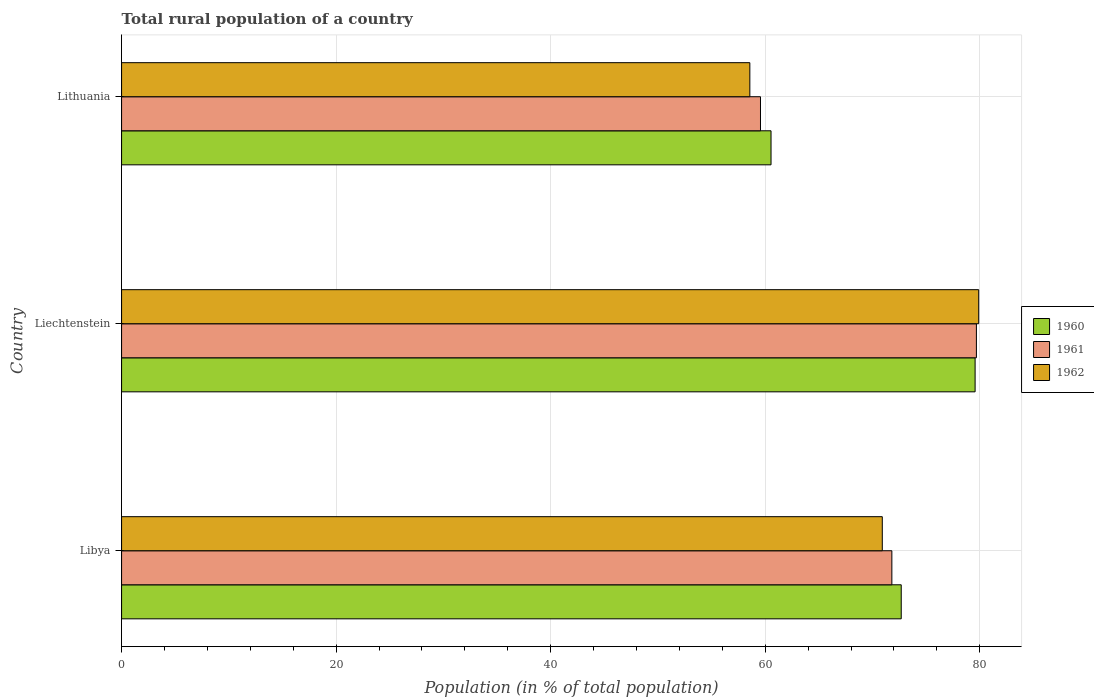How many different coloured bars are there?
Give a very brief answer. 3. Are the number of bars on each tick of the Y-axis equal?
Keep it short and to the point. Yes. How many bars are there on the 2nd tick from the top?
Ensure brevity in your answer.  3. How many bars are there on the 1st tick from the bottom?
Your response must be concise. 3. What is the label of the 1st group of bars from the top?
Provide a short and direct response. Lithuania. What is the rural population in 1962 in Lithuania?
Provide a succinct answer. 58.56. Across all countries, what is the maximum rural population in 1960?
Offer a terse response. 79.56. Across all countries, what is the minimum rural population in 1962?
Your response must be concise. 58.56. In which country was the rural population in 1962 maximum?
Give a very brief answer. Liechtenstein. In which country was the rural population in 1962 minimum?
Keep it short and to the point. Lithuania. What is the total rural population in 1961 in the graph?
Your response must be concise. 211.05. What is the difference between the rural population in 1962 in Libya and that in Liechtenstein?
Offer a terse response. -8.99. What is the difference between the rural population in 1962 in Lithuania and the rural population in 1960 in Libya?
Give a very brief answer. -14.11. What is the average rural population in 1962 per country?
Make the answer very short. 69.79. What is the difference between the rural population in 1961 and rural population in 1960 in Liechtenstein?
Offer a very short reply. 0.12. What is the ratio of the rural population in 1962 in Libya to that in Lithuania?
Provide a succinct answer. 1.21. What is the difference between the highest and the second highest rural population in 1962?
Provide a succinct answer. 8.99. What is the difference between the highest and the lowest rural population in 1961?
Offer a terse response. 20.13. What does the 1st bar from the top in Libya represents?
Provide a short and direct response. 1962. Is it the case that in every country, the sum of the rural population in 1962 and rural population in 1960 is greater than the rural population in 1961?
Offer a very short reply. Yes. How many bars are there?
Offer a very short reply. 9. Are all the bars in the graph horizontal?
Ensure brevity in your answer.  Yes. How many countries are there in the graph?
Offer a very short reply. 3. What is the difference between two consecutive major ticks on the X-axis?
Provide a short and direct response. 20. Does the graph contain any zero values?
Ensure brevity in your answer.  No. Where does the legend appear in the graph?
Offer a very short reply. Center right. How many legend labels are there?
Offer a terse response. 3. What is the title of the graph?
Provide a short and direct response. Total rural population of a country. What is the label or title of the X-axis?
Make the answer very short. Population (in % of total population). What is the label or title of the Y-axis?
Make the answer very short. Country. What is the Population (in % of total population) in 1960 in Libya?
Your answer should be compact. 72.68. What is the Population (in % of total population) of 1961 in Libya?
Keep it short and to the point. 71.8. What is the Population (in % of total population) in 1962 in Libya?
Offer a terse response. 70.91. What is the Population (in % of total population) in 1960 in Liechtenstein?
Offer a very short reply. 79.56. What is the Population (in % of total population) in 1961 in Liechtenstein?
Your answer should be very brief. 79.69. What is the Population (in % of total population) in 1962 in Liechtenstein?
Offer a terse response. 79.9. What is the Population (in % of total population) in 1960 in Lithuania?
Your answer should be very brief. 60.54. What is the Population (in % of total population) of 1961 in Lithuania?
Your answer should be compact. 59.56. What is the Population (in % of total population) in 1962 in Lithuania?
Your response must be concise. 58.56. Across all countries, what is the maximum Population (in % of total population) in 1960?
Your answer should be compact. 79.56. Across all countries, what is the maximum Population (in % of total population) of 1961?
Your response must be concise. 79.69. Across all countries, what is the maximum Population (in % of total population) in 1962?
Provide a short and direct response. 79.9. Across all countries, what is the minimum Population (in % of total population) of 1960?
Make the answer very short. 60.54. Across all countries, what is the minimum Population (in % of total population) in 1961?
Provide a succinct answer. 59.56. Across all countries, what is the minimum Population (in % of total population) in 1962?
Provide a succinct answer. 58.56. What is the total Population (in % of total population) of 1960 in the graph?
Offer a very short reply. 212.78. What is the total Population (in % of total population) of 1961 in the graph?
Your answer should be compact. 211.04. What is the total Population (in % of total population) of 1962 in the graph?
Offer a very short reply. 209.37. What is the difference between the Population (in % of total population) of 1960 in Libya and that in Liechtenstein?
Provide a succinct answer. -6.89. What is the difference between the Population (in % of total population) in 1961 in Libya and that in Liechtenstein?
Provide a short and direct response. -7.88. What is the difference between the Population (in % of total population) of 1962 in Libya and that in Liechtenstein?
Keep it short and to the point. -8.99. What is the difference between the Population (in % of total population) of 1960 in Libya and that in Lithuania?
Your answer should be very brief. 12.14. What is the difference between the Population (in % of total population) of 1961 in Libya and that in Lithuania?
Provide a succinct answer. 12.25. What is the difference between the Population (in % of total population) in 1962 in Libya and that in Lithuania?
Keep it short and to the point. 12.35. What is the difference between the Population (in % of total population) in 1960 in Liechtenstein and that in Lithuania?
Ensure brevity in your answer.  19.02. What is the difference between the Population (in % of total population) of 1961 in Liechtenstein and that in Lithuania?
Keep it short and to the point. 20.13. What is the difference between the Population (in % of total population) in 1962 in Liechtenstein and that in Lithuania?
Make the answer very short. 21.33. What is the difference between the Population (in % of total population) of 1960 in Libya and the Population (in % of total population) of 1961 in Liechtenstein?
Provide a succinct answer. -7.01. What is the difference between the Population (in % of total population) of 1960 in Libya and the Population (in % of total population) of 1962 in Liechtenstein?
Give a very brief answer. -7.22. What is the difference between the Population (in % of total population) of 1961 in Libya and the Population (in % of total population) of 1962 in Liechtenstein?
Your answer should be very brief. -8.1. What is the difference between the Population (in % of total population) of 1960 in Libya and the Population (in % of total population) of 1961 in Lithuania?
Provide a short and direct response. 13.12. What is the difference between the Population (in % of total population) in 1960 in Libya and the Population (in % of total population) in 1962 in Lithuania?
Give a very brief answer. 14.11. What is the difference between the Population (in % of total population) of 1961 in Libya and the Population (in % of total population) of 1962 in Lithuania?
Give a very brief answer. 13.24. What is the difference between the Population (in % of total population) in 1960 in Liechtenstein and the Population (in % of total population) in 1961 in Lithuania?
Provide a succinct answer. 20.01. What is the difference between the Population (in % of total population) in 1960 in Liechtenstein and the Population (in % of total population) in 1962 in Lithuania?
Make the answer very short. 21. What is the difference between the Population (in % of total population) in 1961 in Liechtenstein and the Population (in % of total population) in 1962 in Lithuania?
Keep it short and to the point. 21.12. What is the average Population (in % of total population) in 1960 per country?
Offer a very short reply. 70.93. What is the average Population (in % of total population) of 1961 per country?
Your answer should be very brief. 70.35. What is the average Population (in % of total population) in 1962 per country?
Provide a short and direct response. 69.79. What is the difference between the Population (in % of total population) in 1960 and Population (in % of total population) in 1961 in Libya?
Make the answer very short. 0.87. What is the difference between the Population (in % of total population) of 1960 and Population (in % of total population) of 1962 in Libya?
Provide a succinct answer. 1.77. What is the difference between the Population (in % of total population) in 1961 and Population (in % of total population) in 1962 in Libya?
Keep it short and to the point. 0.89. What is the difference between the Population (in % of total population) in 1960 and Population (in % of total population) in 1961 in Liechtenstein?
Keep it short and to the point. -0.12. What is the difference between the Population (in % of total population) in 1960 and Population (in % of total population) in 1962 in Liechtenstein?
Offer a very short reply. -0.34. What is the difference between the Population (in % of total population) of 1961 and Population (in % of total population) of 1962 in Liechtenstein?
Keep it short and to the point. -0.21. What is the difference between the Population (in % of total population) in 1960 and Population (in % of total population) in 1962 in Lithuania?
Your answer should be compact. 1.98. What is the difference between the Population (in % of total population) in 1961 and Population (in % of total population) in 1962 in Lithuania?
Keep it short and to the point. 0.99. What is the ratio of the Population (in % of total population) of 1960 in Libya to that in Liechtenstein?
Provide a short and direct response. 0.91. What is the ratio of the Population (in % of total population) in 1961 in Libya to that in Liechtenstein?
Make the answer very short. 0.9. What is the ratio of the Population (in % of total population) in 1962 in Libya to that in Liechtenstein?
Your answer should be compact. 0.89. What is the ratio of the Population (in % of total population) in 1960 in Libya to that in Lithuania?
Your answer should be very brief. 1.2. What is the ratio of the Population (in % of total population) of 1961 in Libya to that in Lithuania?
Make the answer very short. 1.21. What is the ratio of the Population (in % of total population) in 1962 in Libya to that in Lithuania?
Keep it short and to the point. 1.21. What is the ratio of the Population (in % of total population) in 1960 in Liechtenstein to that in Lithuania?
Keep it short and to the point. 1.31. What is the ratio of the Population (in % of total population) of 1961 in Liechtenstein to that in Lithuania?
Your answer should be compact. 1.34. What is the ratio of the Population (in % of total population) in 1962 in Liechtenstein to that in Lithuania?
Ensure brevity in your answer.  1.36. What is the difference between the highest and the second highest Population (in % of total population) in 1960?
Offer a terse response. 6.89. What is the difference between the highest and the second highest Population (in % of total population) in 1961?
Provide a short and direct response. 7.88. What is the difference between the highest and the second highest Population (in % of total population) in 1962?
Your answer should be compact. 8.99. What is the difference between the highest and the lowest Population (in % of total population) of 1960?
Ensure brevity in your answer.  19.02. What is the difference between the highest and the lowest Population (in % of total population) in 1961?
Give a very brief answer. 20.13. What is the difference between the highest and the lowest Population (in % of total population) in 1962?
Provide a short and direct response. 21.33. 